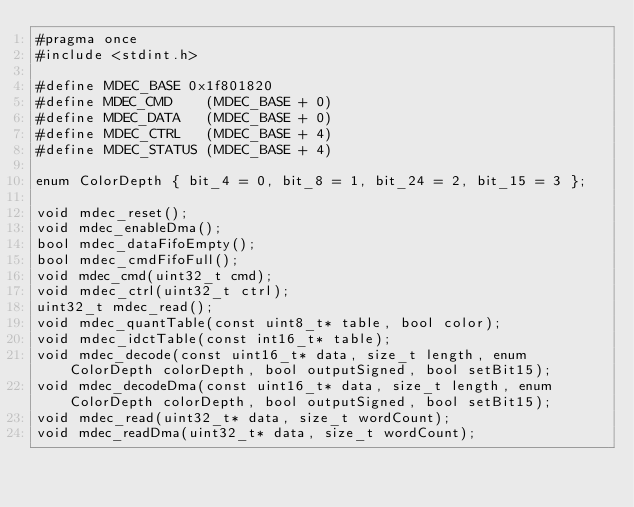<code> <loc_0><loc_0><loc_500><loc_500><_C_>#pragma once
#include <stdint.h>

#define MDEC_BASE 0x1f801820
#define MDEC_CMD    (MDEC_BASE + 0)
#define MDEC_DATA   (MDEC_BASE + 0)
#define MDEC_CTRL   (MDEC_BASE + 4)
#define MDEC_STATUS (MDEC_BASE + 4)

enum ColorDepth { bit_4 = 0, bit_8 = 1, bit_24 = 2, bit_15 = 3 };

void mdec_reset();
void mdec_enableDma();
bool mdec_dataFifoEmpty();
bool mdec_cmdFifoFull();
void mdec_cmd(uint32_t cmd);
void mdec_ctrl(uint32_t ctrl);
uint32_t mdec_read();
void mdec_quantTable(const uint8_t* table, bool color);
void mdec_idctTable(const int16_t* table);
void mdec_decode(const uint16_t* data, size_t length, enum ColorDepth colorDepth, bool outputSigned, bool setBit15);
void mdec_decodeDma(const uint16_t* data, size_t length, enum ColorDepth colorDepth, bool outputSigned, bool setBit15);
void mdec_read(uint32_t* data, size_t wordCount);
void mdec_readDma(uint32_t* data, size_t wordCount);</code> 